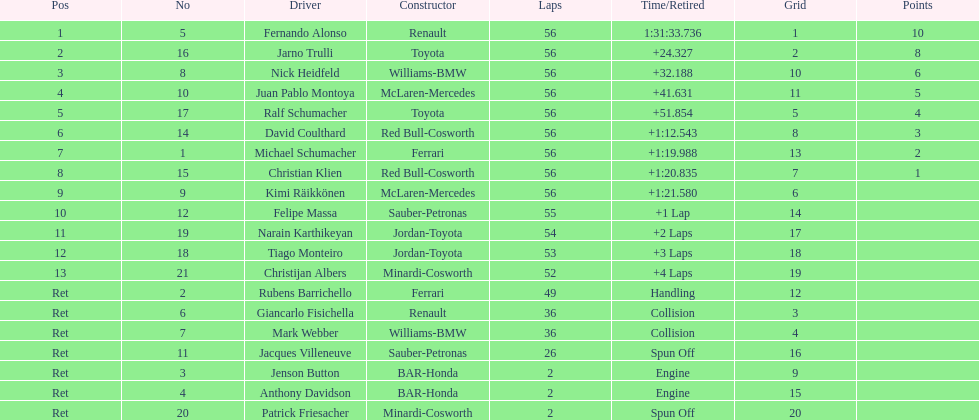How many drivers retired before the race could finish? 7. 